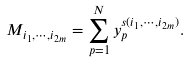<formula> <loc_0><loc_0><loc_500><loc_500>M _ { i _ { 1 } , \cdots , i _ { 2 m } } = \sum _ { p = 1 } ^ { N } y _ { p } ^ { s ( i _ { 1 } , \cdots , i _ { 2 m } ) } .</formula> 